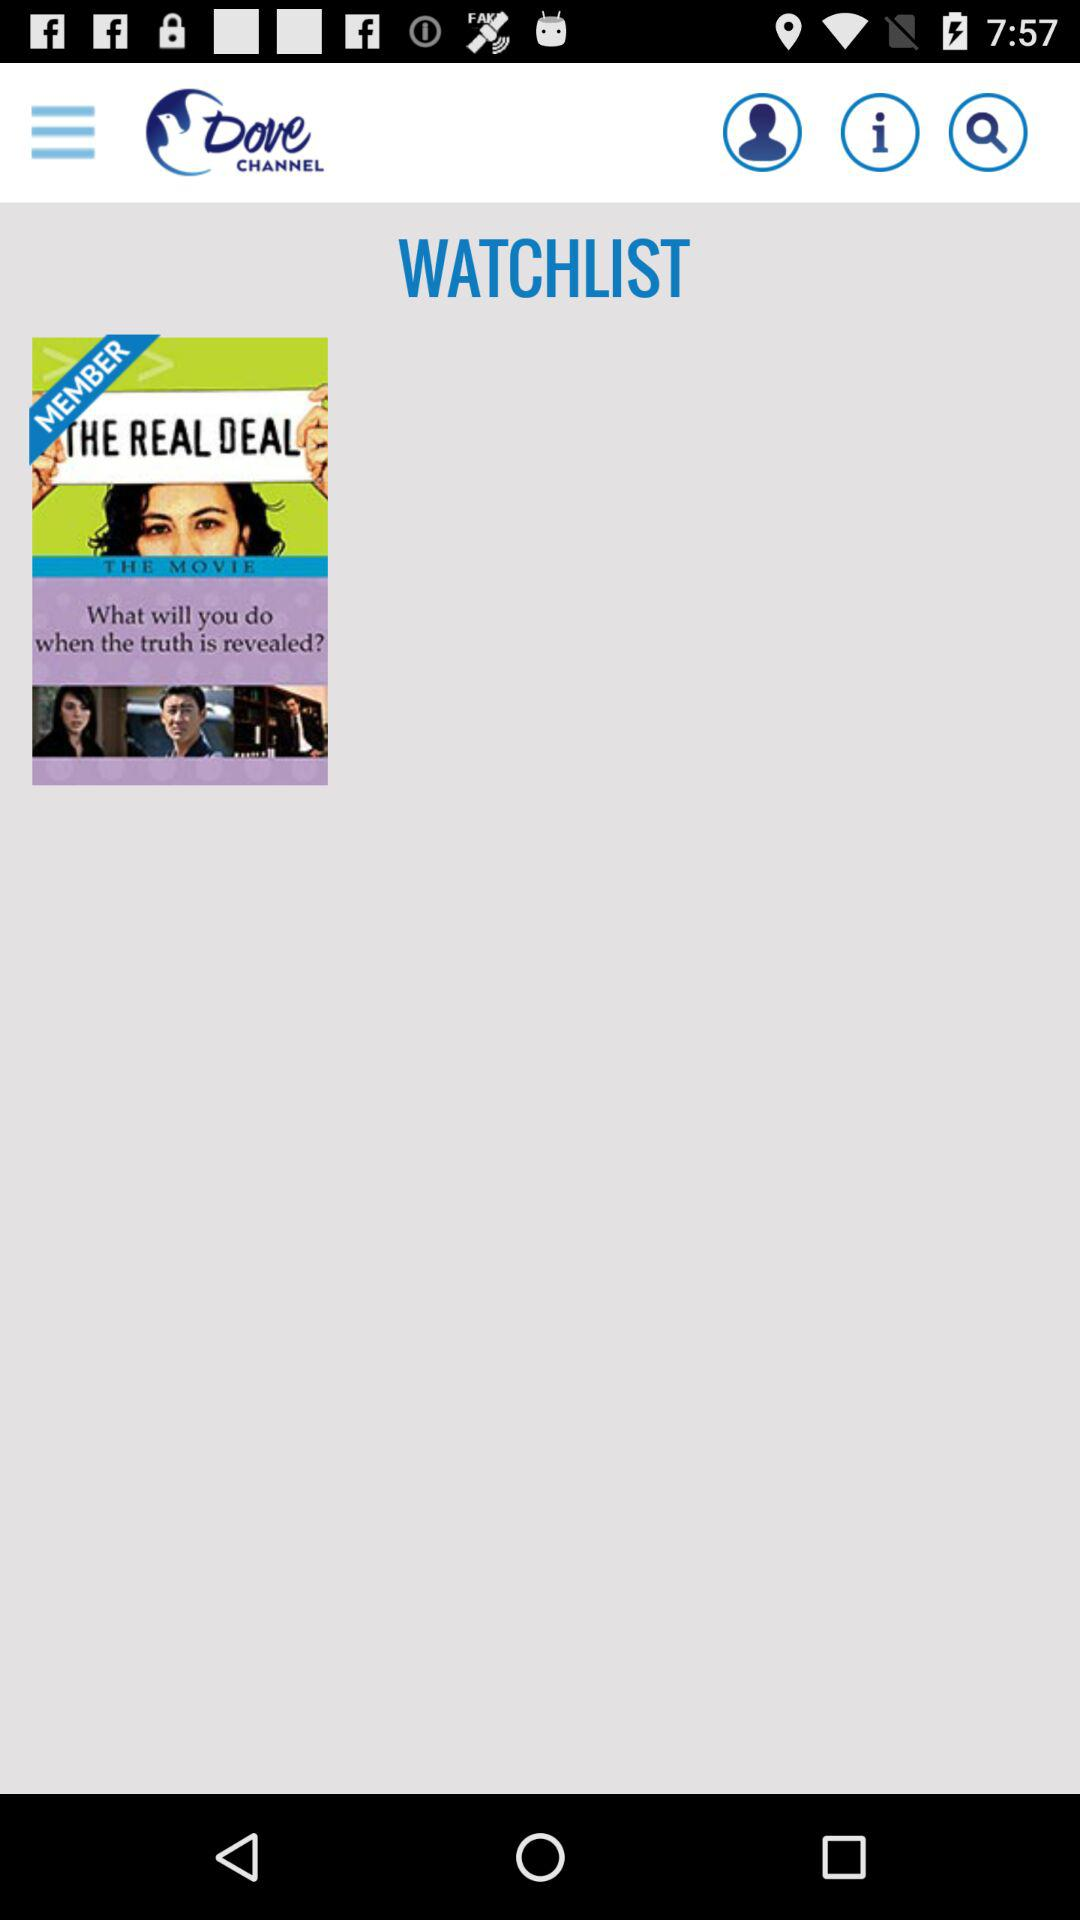What is the name of the application? The name of the application is "Dove Channel". 